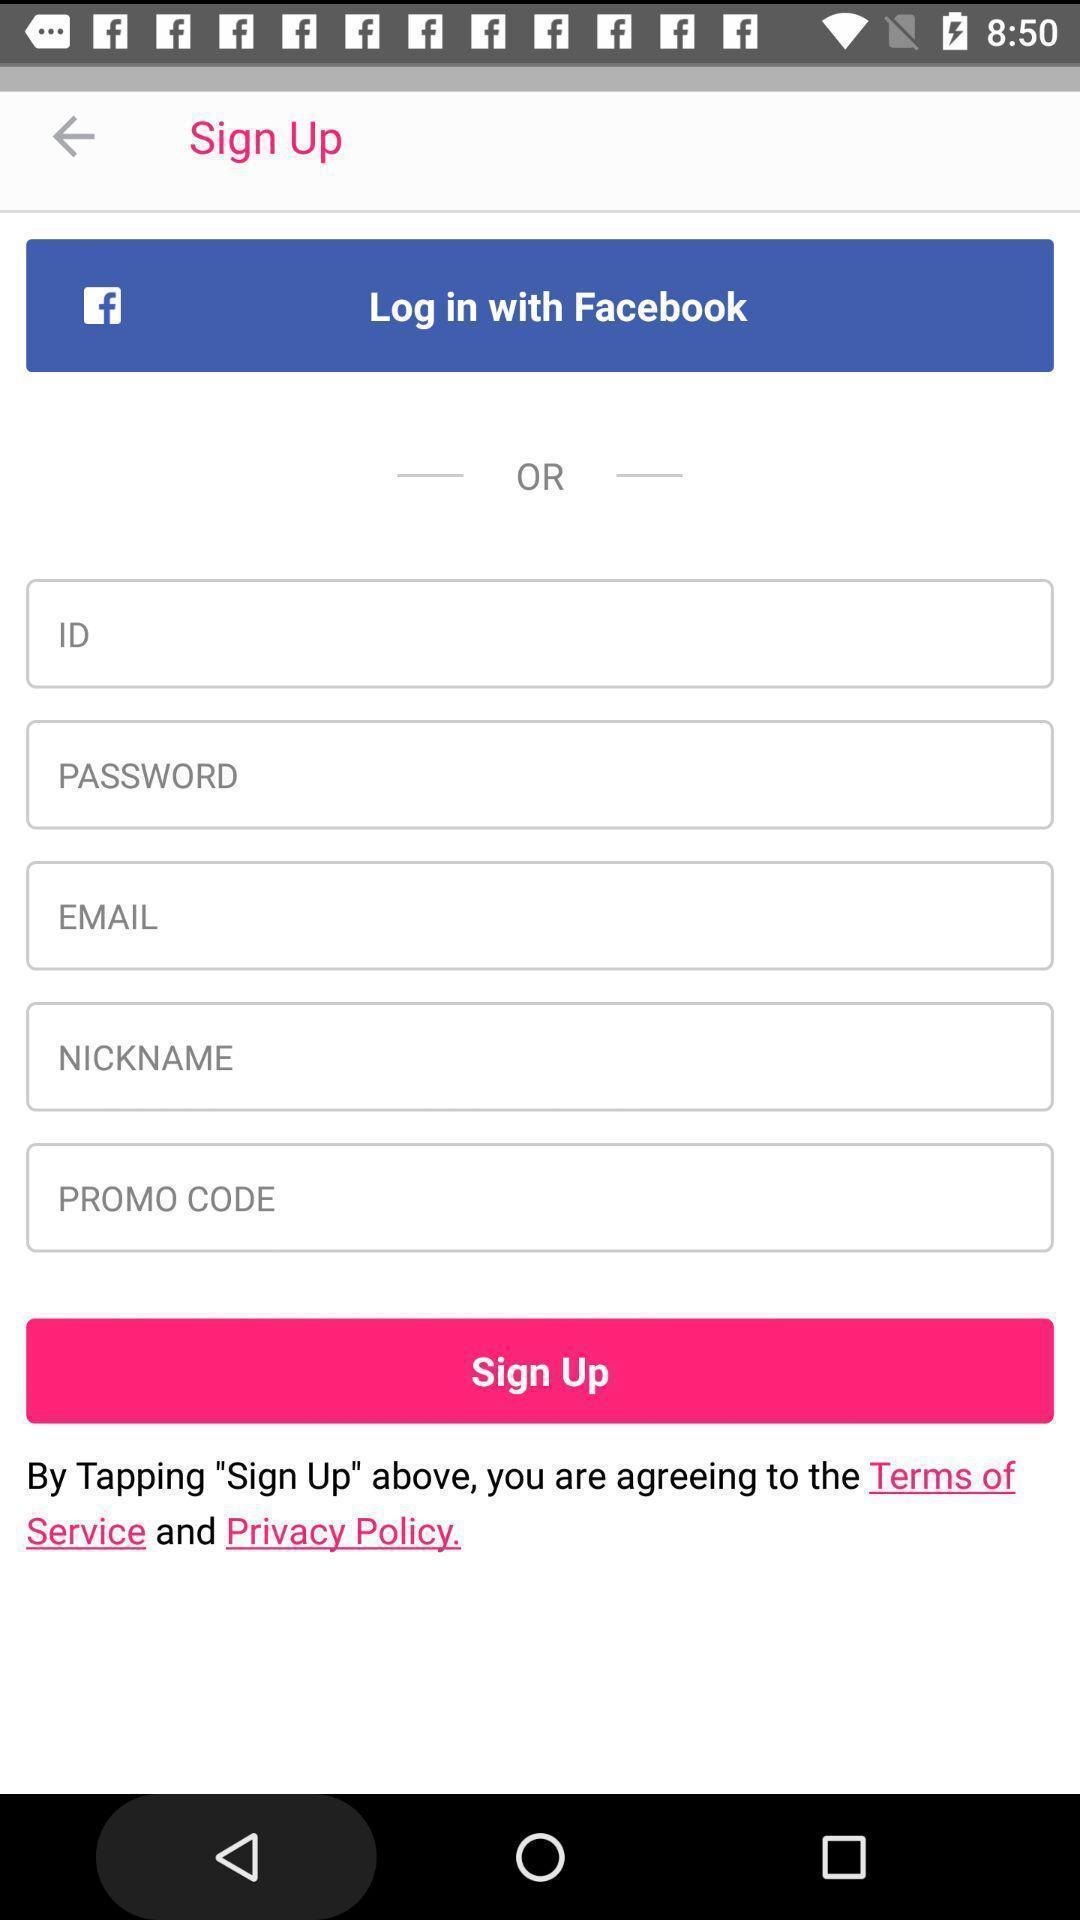Explain the elements present in this screenshot. Sign-up page with social app login option. 